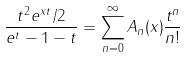Convert formula to latex. <formula><loc_0><loc_0><loc_500><loc_500>\frac { t ^ { 2 } e ^ { x t } / 2 } { e ^ { t } - 1 - t } = \sum _ { n = 0 } ^ { \infty } A _ { n } ( x ) \frac { t ^ { n } } { n ! }</formula> 